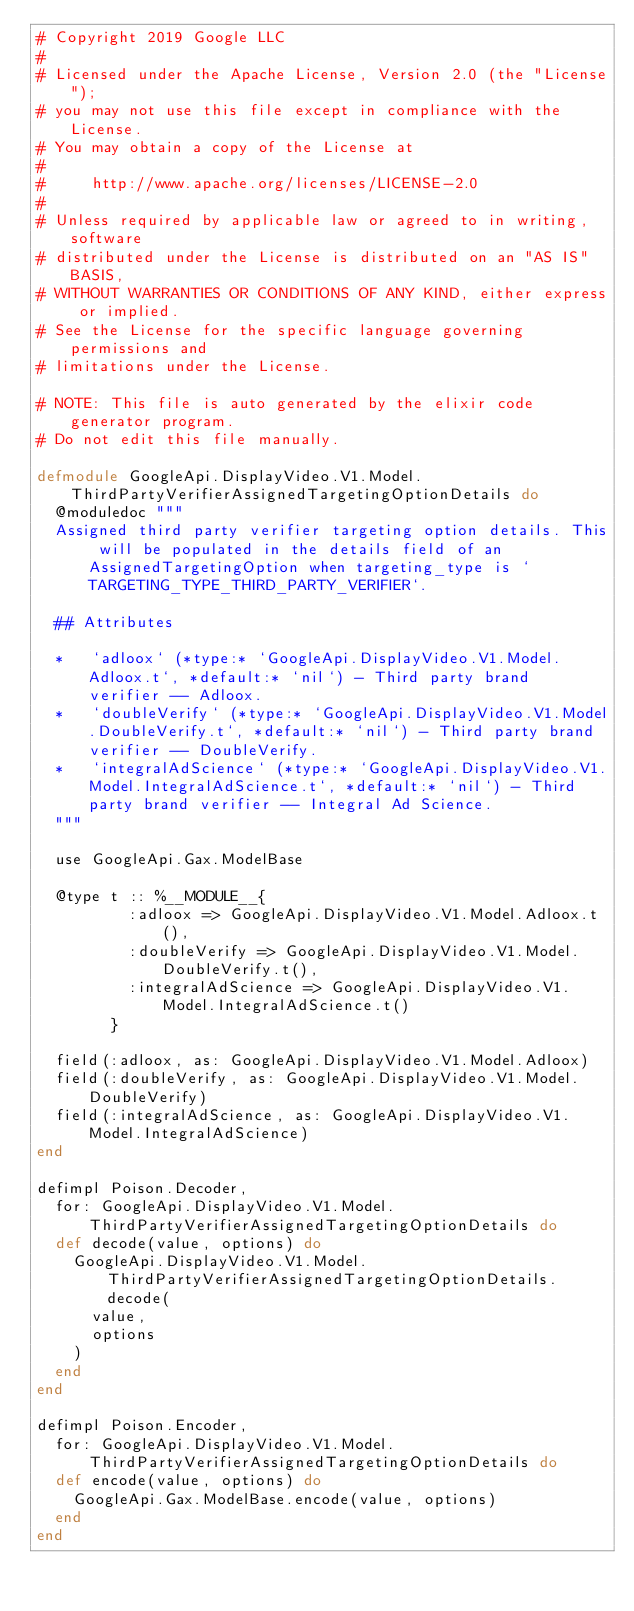<code> <loc_0><loc_0><loc_500><loc_500><_Elixir_># Copyright 2019 Google LLC
#
# Licensed under the Apache License, Version 2.0 (the "License");
# you may not use this file except in compliance with the License.
# You may obtain a copy of the License at
#
#     http://www.apache.org/licenses/LICENSE-2.0
#
# Unless required by applicable law or agreed to in writing, software
# distributed under the License is distributed on an "AS IS" BASIS,
# WITHOUT WARRANTIES OR CONDITIONS OF ANY KIND, either express or implied.
# See the License for the specific language governing permissions and
# limitations under the License.

# NOTE: This file is auto generated by the elixir code generator program.
# Do not edit this file manually.

defmodule GoogleApi.DisplayVideo.V1.Model.ThirdPartyVerifierAssignedTargetingOptionDetails do
  @moduledoc """
  Assigned third party verifier targeting option details. This will be populated in the details field of an AssignedTargetingOption when targeting_type is `TARGETING_TYPE_THIRD_PARTY_VERIFIER`.

  ## Attributes

  *   `adloox` (*type:* `GoogleApi.DisplayVideo.V1.Model.Adloox.t`, *default:* `nil`) - Third party brand verifier -- Adloox.
  *   `doubleVerify` (*type:* `GoogleApi.DisplayVideo.V1.Model.DoubleVerify.t`, *default:* `nil`) - Third party brand verifier -- DoubleVerify.
  *   `integralAdScience` (*type:* `GoogleApi.DisplayVideo.V1.Model.IntegralAdScience.t`, *default:* `nil`) - Third party brand verifier -- Integral Ad Science.
  """

  use GoogleApi.Gax.ModelBase

  @type t :: %__MODULE__{
          :adloox => GoogleApi.DisplayVideo.V1.Model.Adloox.t(),
          :doubleVerify => GoogleApi.DisplayVideo.V1.Model.DoubleVerify.t(),
          :integralAdScience => GoogleApi.DisplayVideo.V1.Model.IntegralAdScience.t()
        }

  field(:adloox, as: GoogleApi.DisplayVideo.V1.Model.Adloox)
  field(:doubleVerify, as: GoogleApi.DisplayVideo.V1.Model.DoubleVerify)
  field(:integralAdScience, as: GoogleApi.DisplayVideo.V1.Model.IntegralAdScience)
end

defimpl Poison.Decoder,
  for: GoogleApi.DisplayVideo.V1.Model.ThirdPartyVerifierAssignedTargetingOptionDetails do
  def decode(value, options) do
    GoogleApi.DisplayVideo.V1.Model.ThirdPartyVerifierAssignedTargetingOptionDetails.decode(
      value,
      options
    )
  end
end

defimpl Poison.Encoder,
  for: GoogleApi.DisplayVideo.V1.Model.ThirdPartyVerifierAssignedTargetingOptionDetails do
  def encode(value, options) do
    GoogleApi.Gax.ModelBase.encode(value, options)
  end
end
</code> 